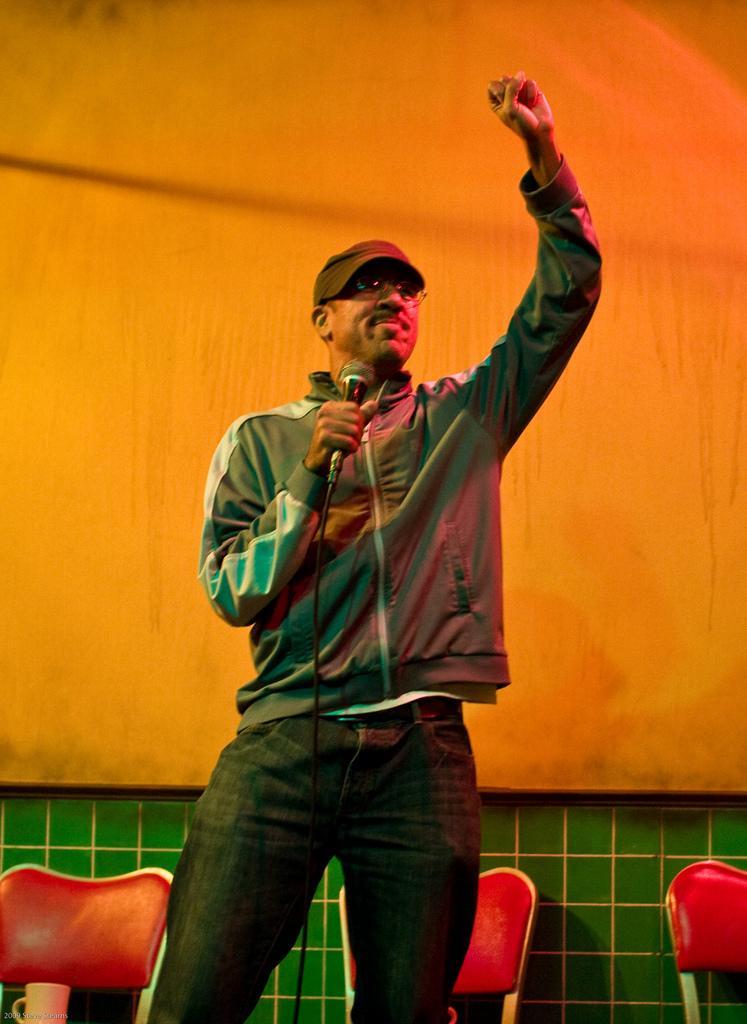Can you describe this image briefly? In this image we can see a man wearing cap and specs. And he is holding a mic. In the back there are chairs. Also there is a wall. At the bottom there is a cup. 